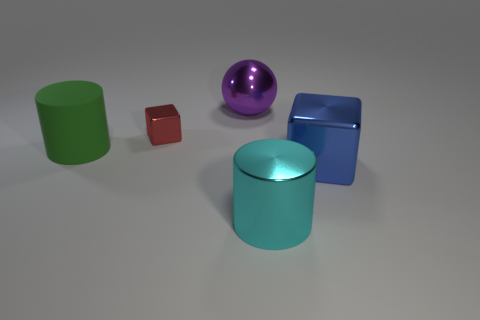Add 3 blue metal cubes. How many objects exist? 8 Subtract all cylinders. How many objects are left? 3 Add 5 big green things. How many big green things are left? 6 Add 4 big green matte things. How many big green matte things exist? 5 Subtract 1 purple balls. How many objects are left? 4 Subtract all small red cubes. Subtract all yellow metal things. How many objects are left? 4 